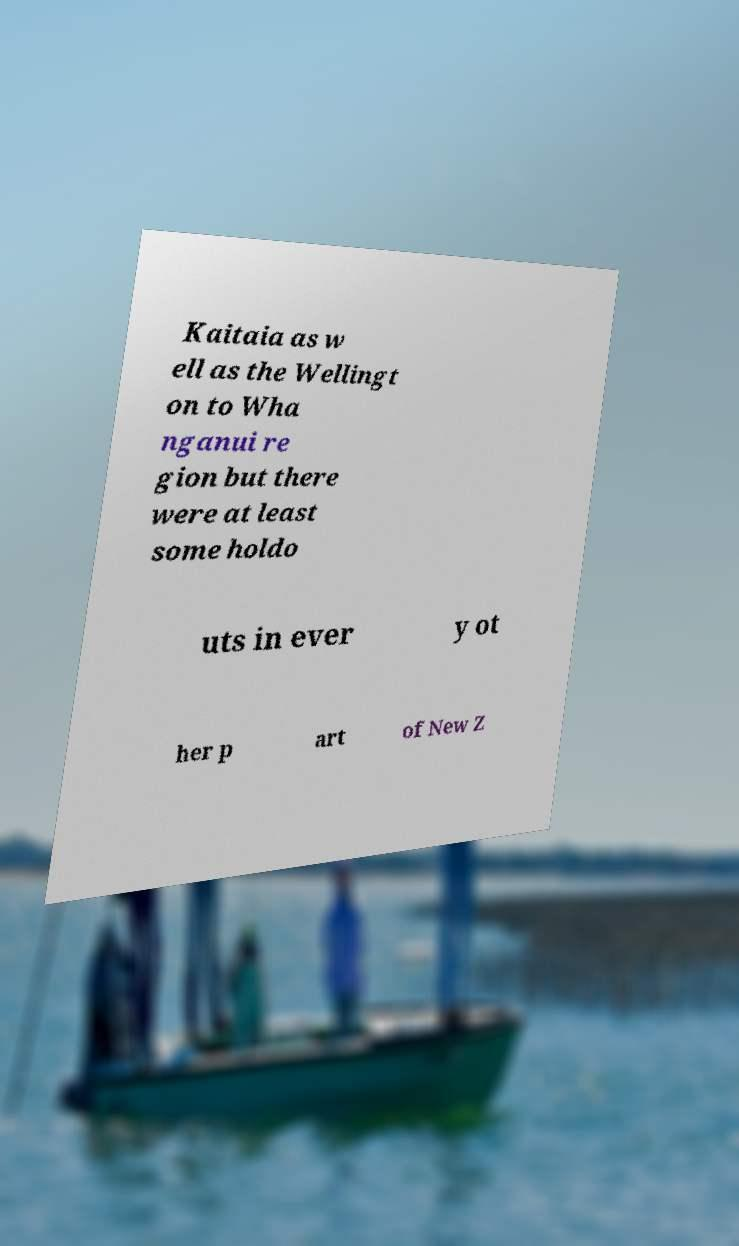For documentation purposes, I need the text within this image transcribed. Could you provide that? Kaitaia as w ell as the Wellingt on to Wha nganui re gion but there were at least some holdo uts in ever y ot her p art of New Z 